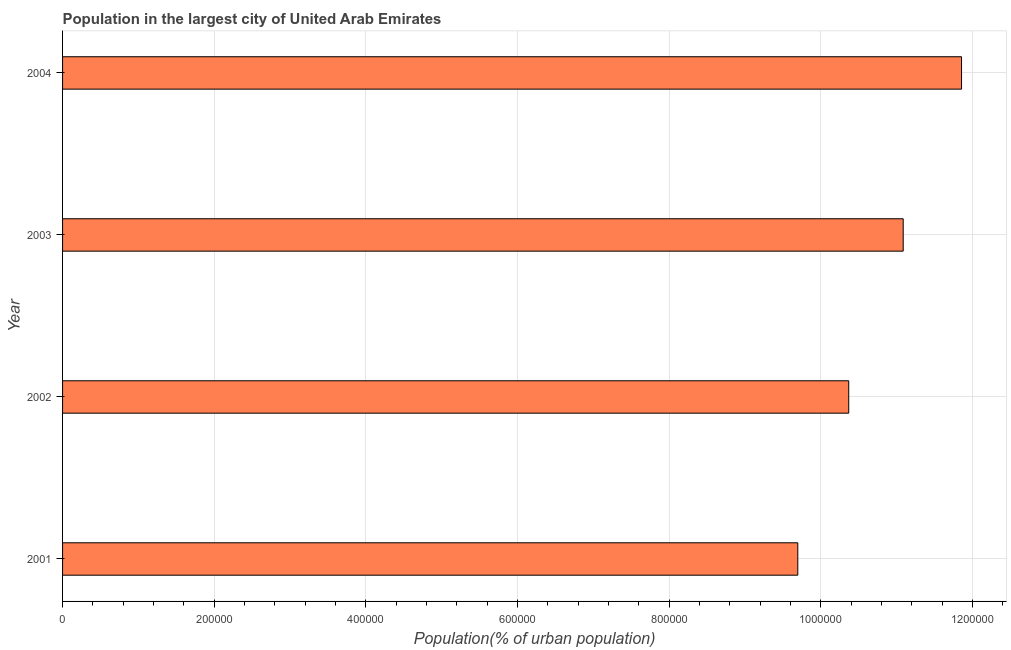Does the graph contain grids?
Provide a short and direct response. Yes. What is the title of the graph?
Keep it short and to the point. Population in the largest city of United Arab Emirates. What is the label or title of the X-axis?
Your answer should be very brief. Population(% of urban population). What is the label or title of the Y-axis?
Your response must be concise. Year. What is the population in largest city in 2001?
Provide a short and direct response. 9.70e+05. Across all years, what is the maximum population in largest city?
Your response must be concise. 1.19e+06. Across all years, what is the minimum population in largest city?
Your answer should be compact. 9.70e+05. What is the sum of the population in largest city?
Give a very brief answer. 4.30e+06. What is the difference between the population in largest city in 2001 and 2004?
Offer a terse response. -2.16e+05. What is the average population in largest city per year?
Your response must be concise. 1.08e+06. What is the median population in largest city?
Make the answer very short. 1.07e+06. In how many years, is the population in largest city greater than 120000 %?
Offer a terse response. 4. Do a majority of the years between 2002 and 2003 (inclusive) have population in largest city greater than 120000 %?
Offer a terse response. Yes. What is the ratio of the population in largest city in 2003 to that in 2004?
Your response must be concise. 0.94. Is the population in largest city in 2001 less than that in 2003?
Ensure brevity in your answer.  Yes. Is the difference between the population in largest city in 2001 and 2004 greater than the difference between any two years?
Provide a succinct answer. Yes. What is the difference between the highest and the second highest population in largest city?
Keep it short and to the point. 7.69e+04. What is the difference between the highest and the lowest population in largest city?
Give a very brief answer. 2.16e+05. In how many years, is the population in largest city greater than the average population in largest city taken over all years?
Your answer should be compact. 2. Are the values on the major ticks of X-axis written in scientific E-notation?
Your answer should be very brief. No. What is the Population(% of urban population) of 2001?
Your response must be concise. 9.70e+05. What is the Population(% of urban population) in 2002?
Provide a short and direct response. 1.04e+06. What is the Population(% of urban population) in 2003?
Offer a terse response. 1.11e+06. What is the Population(% of urban population) in 2004?
Your answer should be very brief. 1.19e+06. What is the difference between the Population(% of urban population) in 2001 and 2002?
Offer a terse response. -6.72e+04. What is the difference between the Population(% of urban population) in 2001 and 2003?
Your answer should be compact. -1.39e+05. What is the difference between the Population(% of urban population) in 2001 and 2004?
Your response must be concise. -2.16e+05. What is the difference between the Population(% of urban population) in 2002 and 2003?
Make the answer very short. -7.19e+04. What is the difference between the Population(% of urban population) in 2002 and 2004?
Your answer should be compact. -1.49e+05. What is the difference between the Population(% of urban population) in 2003 and 2004?
Keep it short and to the point. -7.69e+04. What is the ratio of the Population(% of urban population) in 2001 to that in 2002?
Your answer should be very brief. 0.94. What is the ratio of the Population(% of urban population) in 2001 to that in 2003?
Offer a very short reply. 0.88. What is the ratio of the Population(% of urban population) in 2001 to that in 2004?
Offer a very short reply. 0.82. What is the ratio of the Population(% of urban population) in 2002 to that in 2003?
Provide a short and direct response. 0.94. What is the ratio of the Population(% of urban population) in 2003 to that in 2004?
Ensure brevity in your answer.  0.94. 